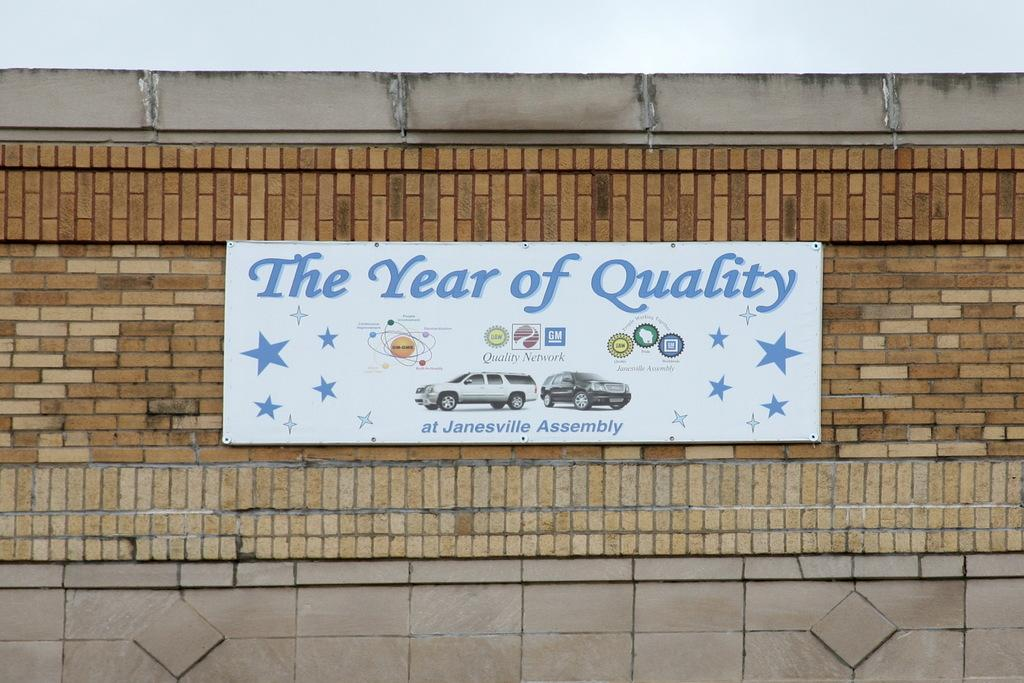What is the main object in the image? There is a board in the image. What can be found on the board? The board has text and images on it. Where is the board located? The board is on a wall. Can you see any frogs at the seashore in the image? There is no seashore or frogs present in the image; it features a board with text and images on a wall. 